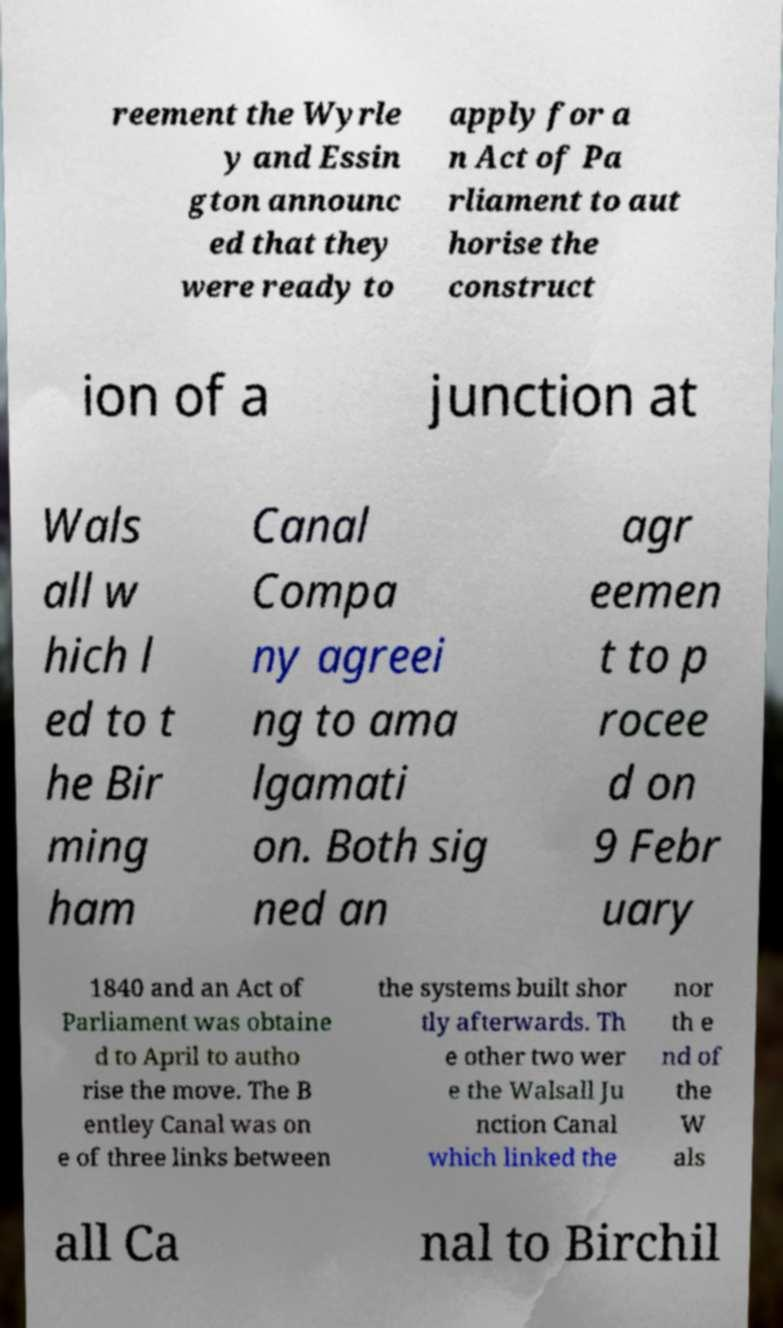For documentation purposes, I need the text within this image transcribed. Could you provide that? reement the Wyrle y and Essin gton announc ed that they were ready to apply for a n Act of Pa rliament to aut horise the construct ion of a junction at Wals all w hich l ed to t he Bir ming ham Canal Compa ny agreei ng to ama lgamati on. Both sig ned an agr eemen t to p rocee d on 9 Febr uary 1840 and an Act of Parliament was obtaine d to April to autho rise the move. The B entley Canal was on e of three links between the systems built shor tly afterwards. Th e other two wer e the Walsall Ju nction Canal which linked the nor th e nd of the W als all Ca nal to Birchil 